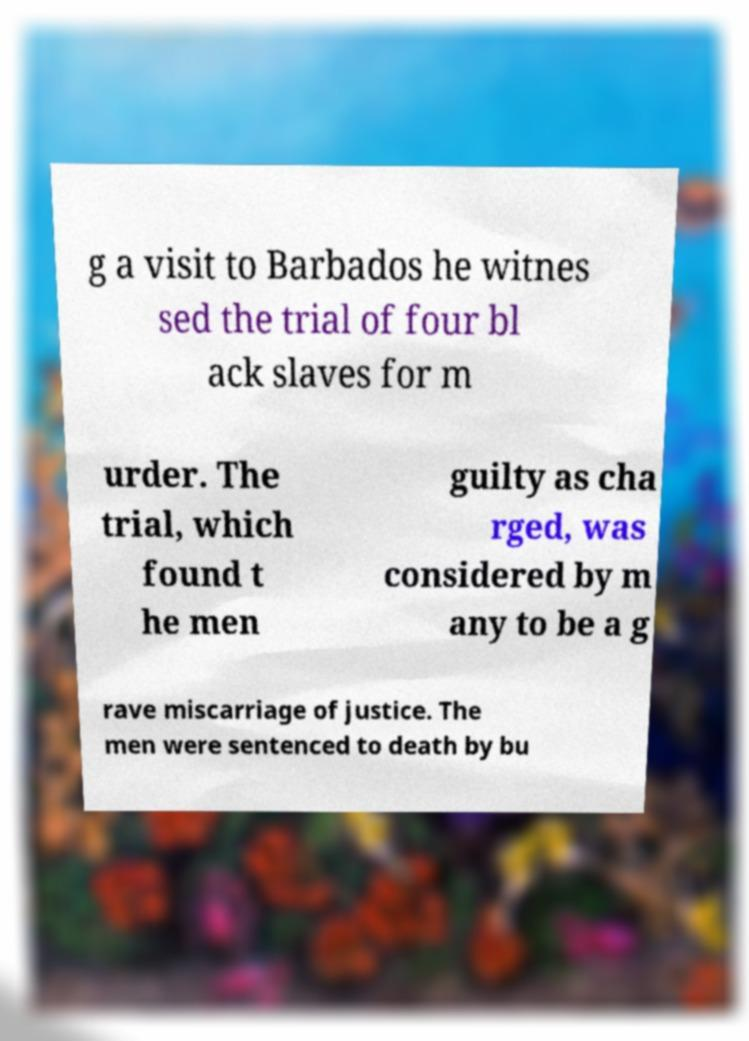Could you extract and type out the text from this image? g a visit to Barbados he witnes sed the trial of four bl ack slaves for m urder. The trial, which found t he men guilty as cha rged, was considered by m any to be a g rave miscarriage of justice. The men were sentenced to death by bu 